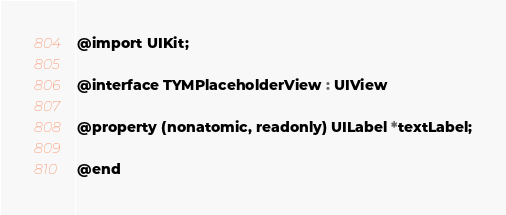Convert code to text. <code><loc_0><loc_0><loc_500><loc_500><_C_>@import UIKit;

@interface TYMPlaceholderView : UIView

@property (nonatomic, readonly) UILabel *textLabel;

@end
</code> 